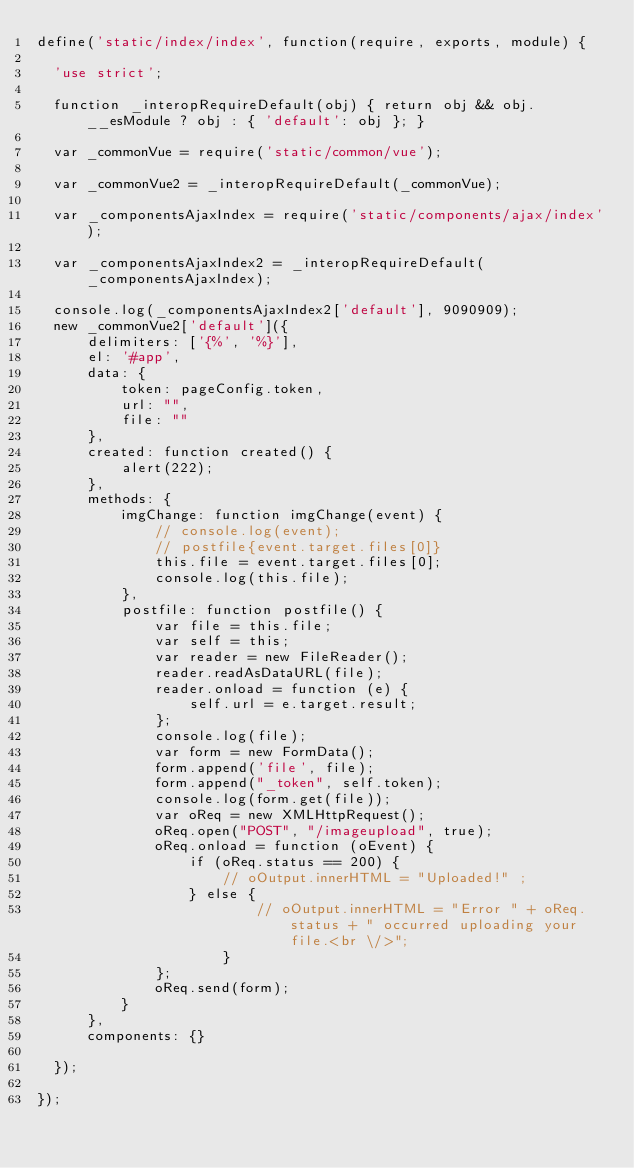Convert code to text. <code><loc_0><loc_0><loc_500><loc_500><_JavaScript_>define('static/index/index', function(require, exports, module) {

  'use strict';
  
  function _interopRequireDefault(obj) { return obj && obj.__esModule ? obj : { 'default': obj }; }
  
  var _commonVue = require('static/common/vue');
  
  var _commonVue2 = _interopRequireDefault(_commonVue);
  
  var _componentsAjaxIndex = require('static/components/ajax/index');
  
  var _componentsAjaxIndex2 = _interopRequireDefault(_componentsAjaxIndex);
  
  console.log(_componentsAjaxIndex2['default'], 9090909);
  new _commonVue2['default']({
      delimiters: ['{%', '%}'],
      el: '#app',
      data: {
          token: pageConfig.token,
          url: "",
          file: ""
      },
      created: function created() {
          alert(222);
      },
      methods: {
          imgChange: function imgChange(event) {
              // console.log(event);
              // postfile{event.target.files[0]}
              this.file = event.target.files[0];
              console.log(this.file);
          },
          postfile: function postfile() {
              var file = this.file;
              var self = this;
              var reader = new FileReader();
              reader.readAsDataURL(file);
              reader.onload = function (e) {
                  self.url = e.target.result;
              };
              console.log(file);
              var form = new FormData();
              form.append('file', file);
              form.append("_token", self.token);
              console.log(form.get(file));
              var oReq = new XMLHttpRequest();
              oReq.open("POST", "/imageupload", true);
              oReq.onload = function (oEvent) {
                  if (oReq.status == 200) {
                      // oOutput.innerHTML = "Uploaded!" ; 
                  } else {
                          // oOutput.innerHTML = "Error " + oReq.status + " occurred uploading your file.<br \/>"; 
                      }
              };
              oReq.send(form);
          }
      },
      components: {}
  
  });

});
</code> 